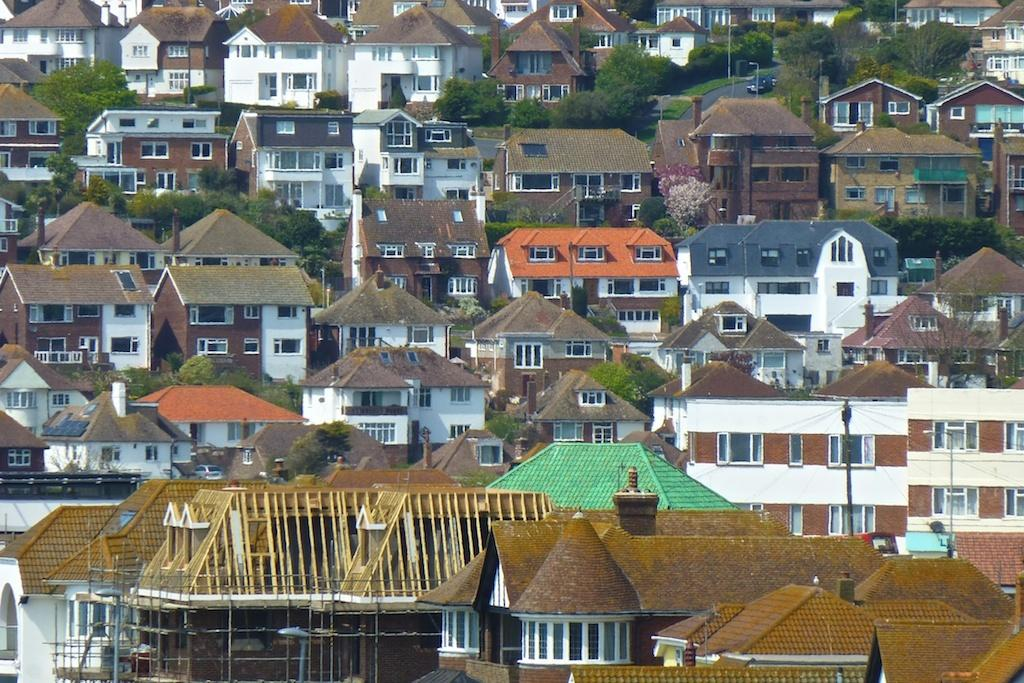What type of structures are present in the image? There are buildings in the image. What feature can be seen on the buildings? The buildings have windows. What type of vegetation is visible in the image? There are trees in the image. How much salt is sprinkled on the trees in the image? There is no salt present in the image, and therefore no salt can be sprinkled on the trees. 